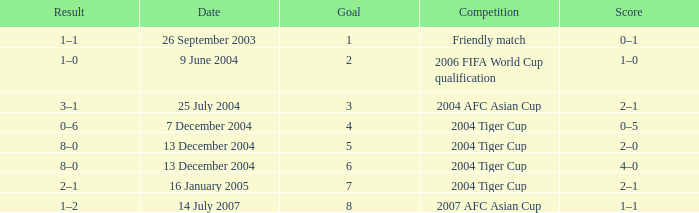I'm looking to parse the entire table for insights. Could you assist me with that? {'header': ['Result', 'Date', 'Goal', 'Competition', 'Score'], 'rows': [['1–1', '26 September 2003', '1', 'Friendly match', '0–1'], ['1–0', '9 June 2004', '2', '2006 FIFA World Cup qualification', '1–0'], ['3–1', '25 July 2004', '3', '2004 AFC Asian Cup', '2–1'], ['0–6', '7 December 2004', '4', '2004 Tiger Cup', '0–5'], ['8–0', '13 December 2004', '5', '2004 Tiger Cup', '2–0'], ['8–0', '13 December 2004', '6', '2004 Tiger Cup', '4–0'], ['2–1', '16 January 2005', '7', '2004 Tiger Cup', '2–1'], ['1–2', '14 July 2007', '8', '2007 AFC Asian Cup', '1–1']]} Which date has 3 as the goal? 25 July 2004. 